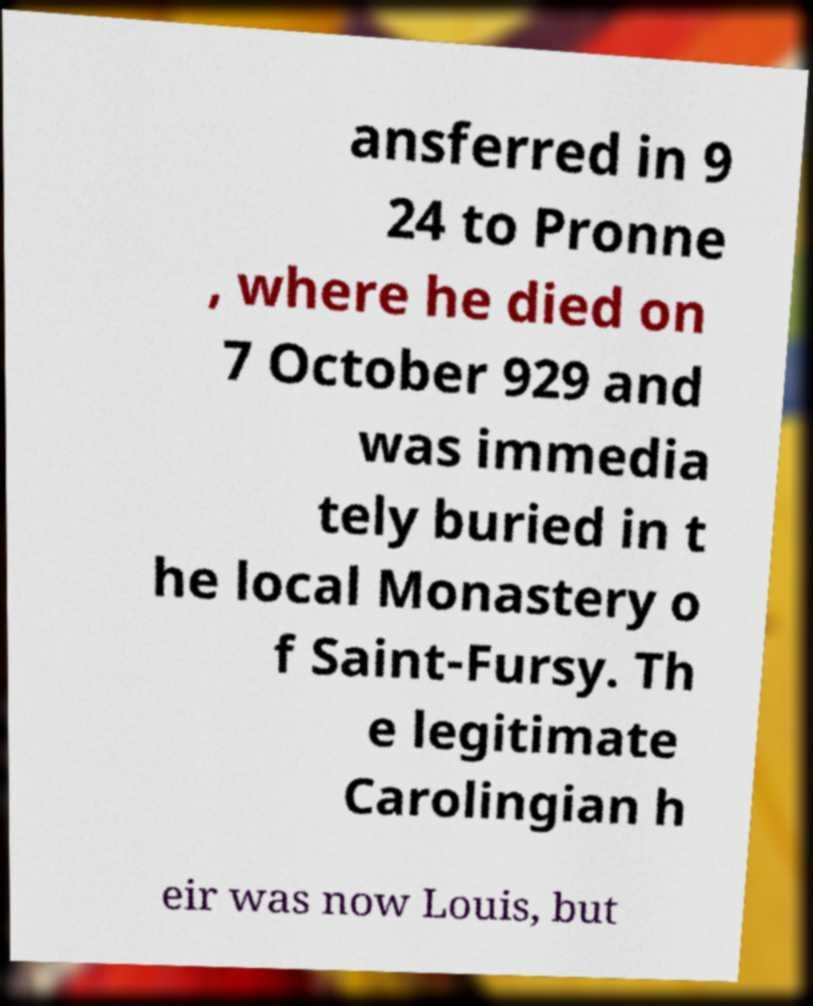For documentation purposes, I need the text within this image transcribed. Could you provide that? ansferred in 9 24 to Pronne , where he died on 7 October 929 and was immedia tely buried in t he local Monastery o f Saint-Fursy. Th e legitimate Carolingian h eir was now Louis, but 